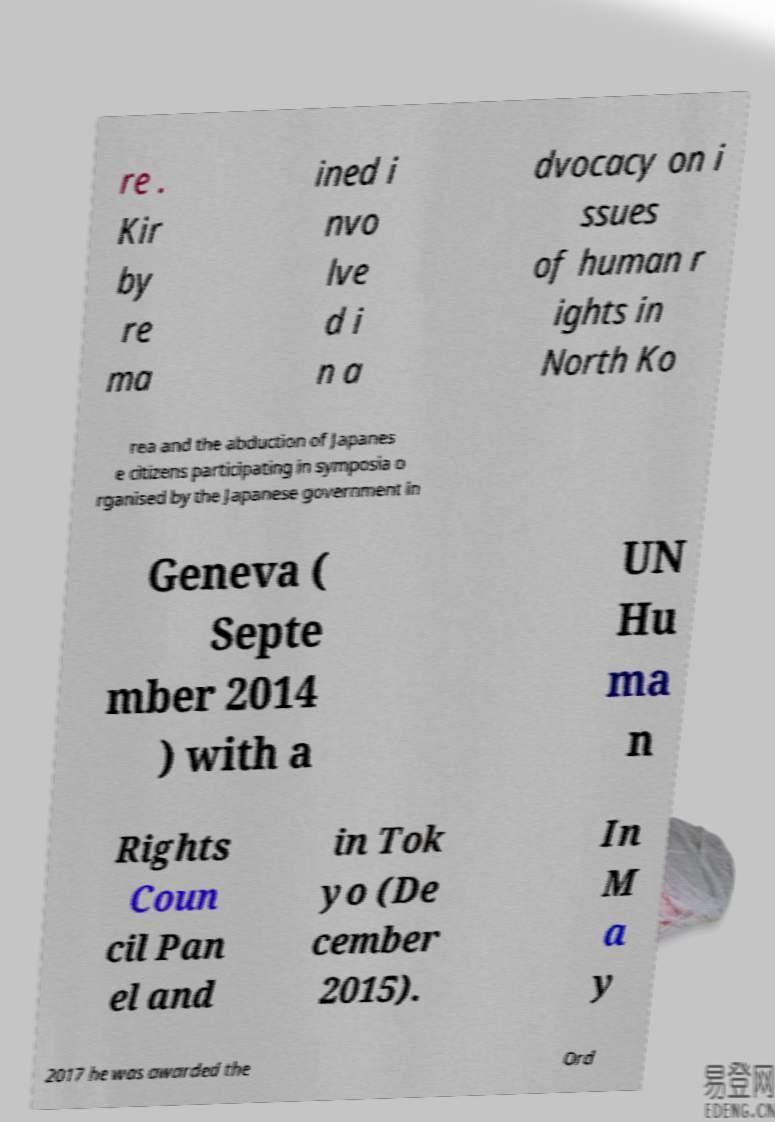Could you extract and type out the text from this image? re . Kir by re ma ined i nvo lve d i n a dvocacy on i ssues of human r ights in North Ko rea and the abduction of Japanes e citizens participating in symposia o rganised by the Japanese government in Geneva ( Septe mber 2014 ) with a UN Hu ma n Rights Coun cil Pan el and in Tok yo (De cember 2015). In M a y 2017 he was awarded the Ord 